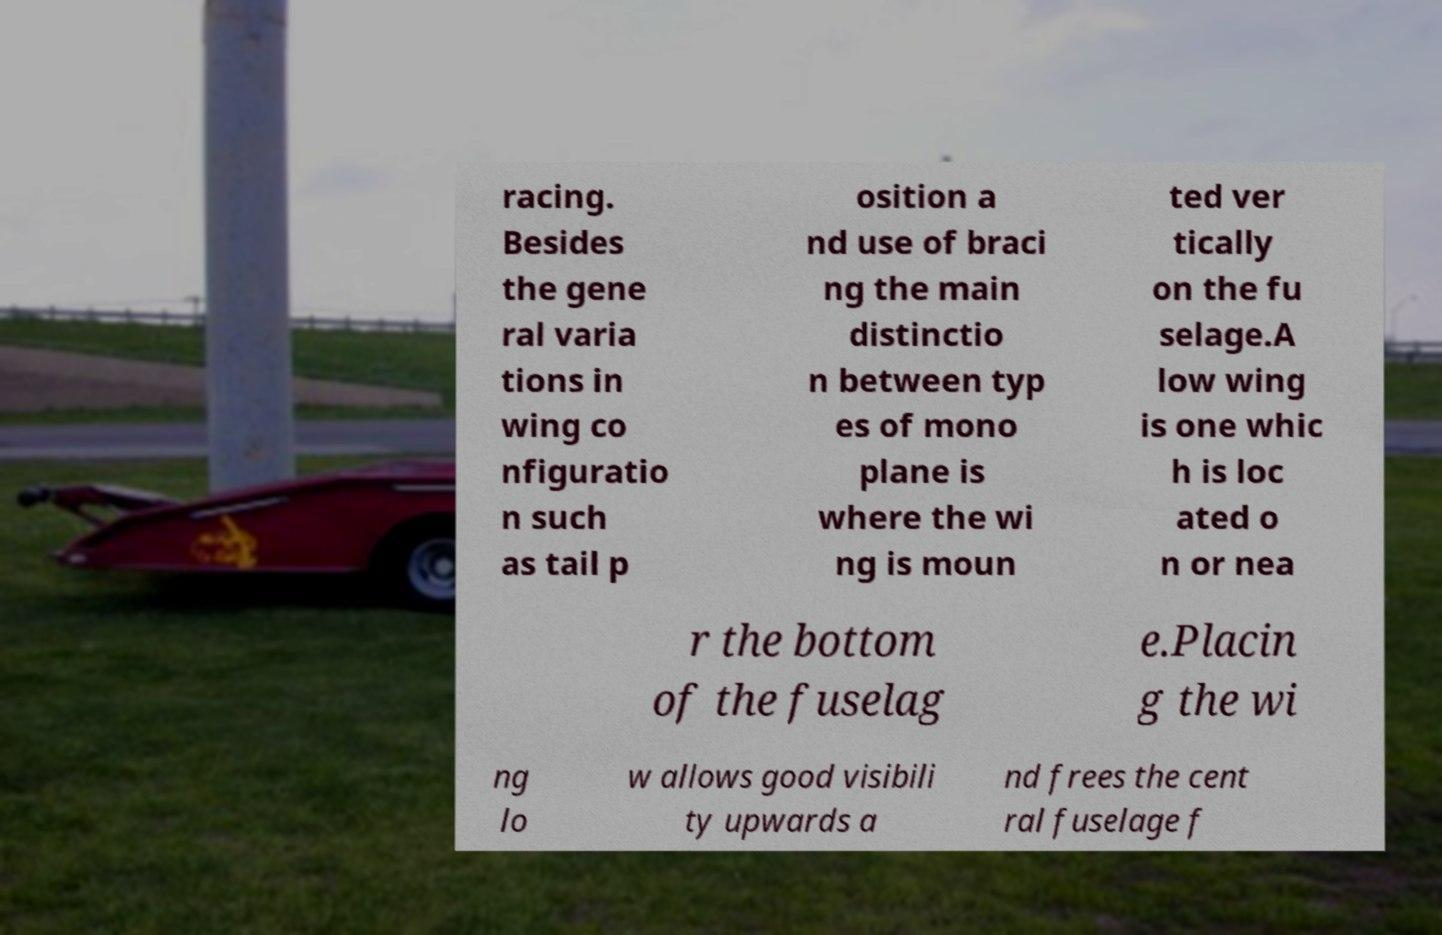Could you assist in decoding the text presented in this image and type it out clearly? racing. Besides the gene ral varia tions in wing co nfiguratio n such as tail p osition a nd use of braci ng the main distinctio n between typ es of mono plane is where the wi ng is moun ted ver tically on the fu selage.A low wing is one whic h is loc ated o n or nea r the bottom of the fuselag e.Placin g the wi ng lo w allows good visibili ty upwards a nd frees the cent ral fuselage f 